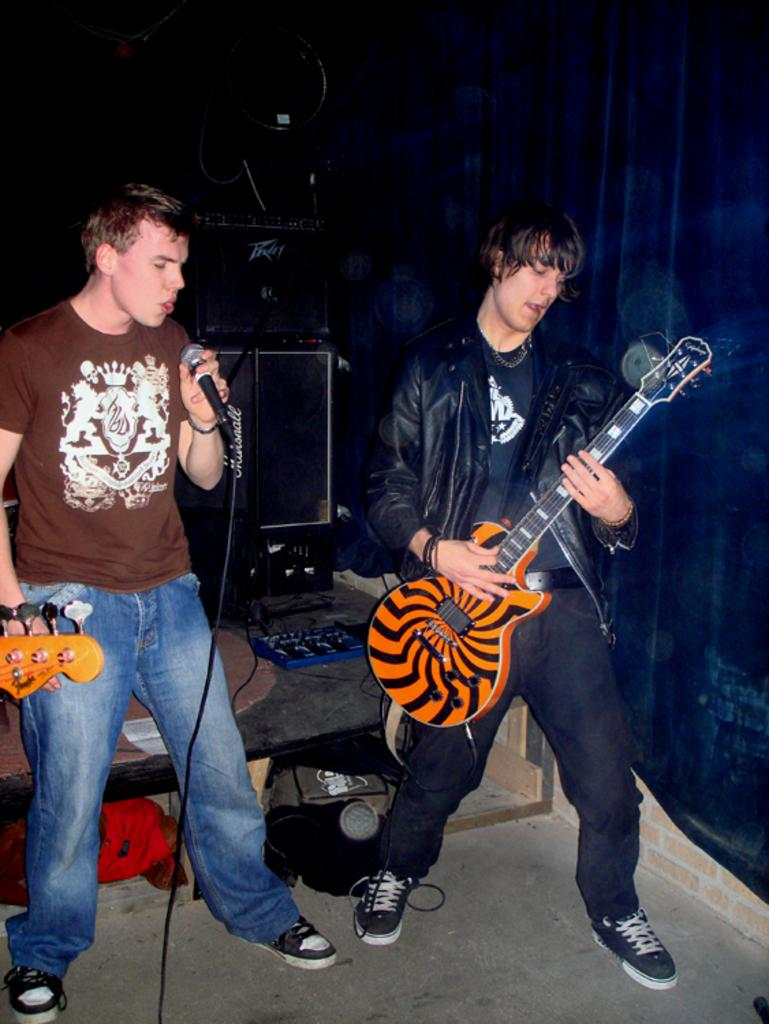What is the man in the image holding? The man is holding a mic in the image. What is the other man in the image holding? The other man is holding a guitar in the image. What can be seen in the background of the image? Equipment is visible in the background of the image. Is there any blood visible on the guitar in the image? No, there is no blood visible on the guitar in the image. Is the man holding the mic in a prison in the image? No, there is no indication of a prison in the image; it appears to be a performance or rehearsal setting. 